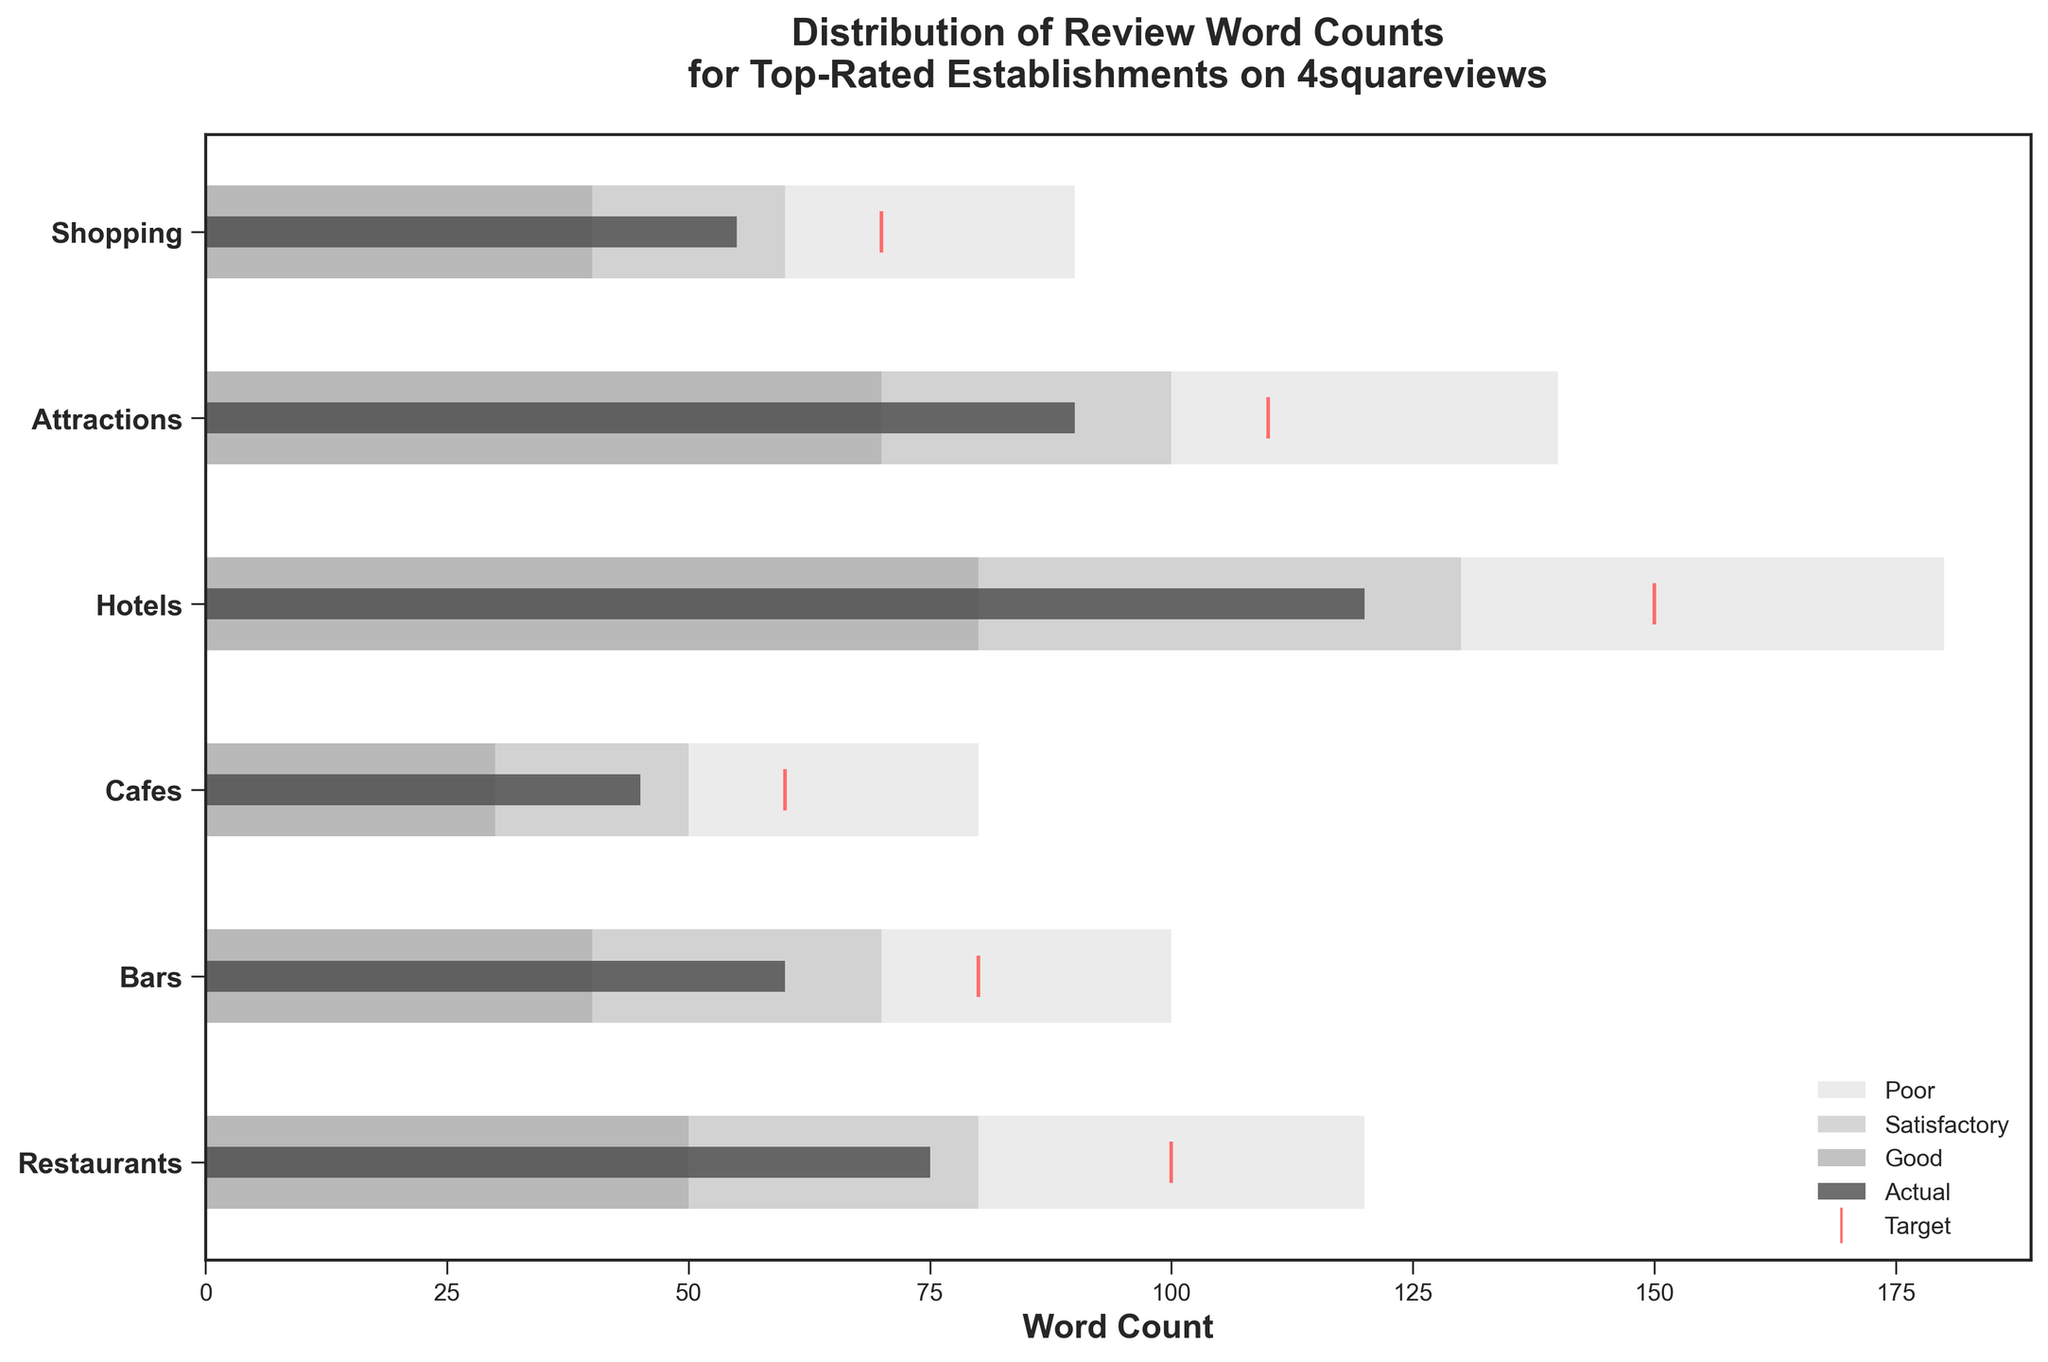What is the title of the figure? The title of the figure is usually located at the top center of the plot. Here, it reads "Distribution of Review Word Counts for Top-Rated Establishments on 4squareviews".
Answer: Distribution of Review Word Counts for Top-Rated Establishments on 4squareviews How many categories are there in the figure? By counting the number of distinct y-tick labels on the vertical axis, we find there are six categories: Restaurants, Bars, Cafes, Hotels, Attractions, and Shopping.
Answer: 6 Which category has the highest target word count? By examining the positions of the red target marks on the horizontal axis, we see that the target word count for Hotels is the highest at 150.
Answer: Hotels How does the actual review word count for Restaurants compare to its target? The actual word count for Restaurants is shown with a dark gray bar that reaches up to 75, while the red target mark is at 100. Thus, the actual word count is 25 less than the target.
Answer: 25 less What is the color representing the "Good" range? The color for the "Good" range is identified in the legend as being a shade of gray distinct from the other ranges. Specifically, it is a medium gray.
Answer: medium gray How does the actual review word count for Cafes compare to the average of its range values? The actual word count for Cafes is 45. The ranges are 30, 50, and 80. The average of the ranges is calculated as (30 + 50 + 80) / 3 = 160 / 3 ≈ 53.33. Thus, the actual count is about 8.33 less than the average.
Answer: 8.33 less Which category has its actual word count within the "Good" range? The actual word counts are marked with dark gray bars and compared against their respective ranges. We observe that the actual word count for Attractions, 90, falls within its "Good" range of 70-100.
Answer: Attractions What is the difference between the actual and target word count for Bars? For Bars, the actual word count is 60 and the target is 80. The difference is 80 - 60 = 20.
Answer: 20 Which categories have an actual word count lower than their "Poor" range? By comparing the dark gray bars representing actual values with the leftmost end of the "Poor" ranges, we find that no category has an actual word count lower than their "Poor" range.
Answer: None Is the actual word count for Shopping more or less than the satisfactory range? The satisfactory range for Shopping is from 40 to 60. The actual word count is 55, which falls within this range. Therefore, it is neither more nor less, but within the satisfactory range.
Answer: Within the range 